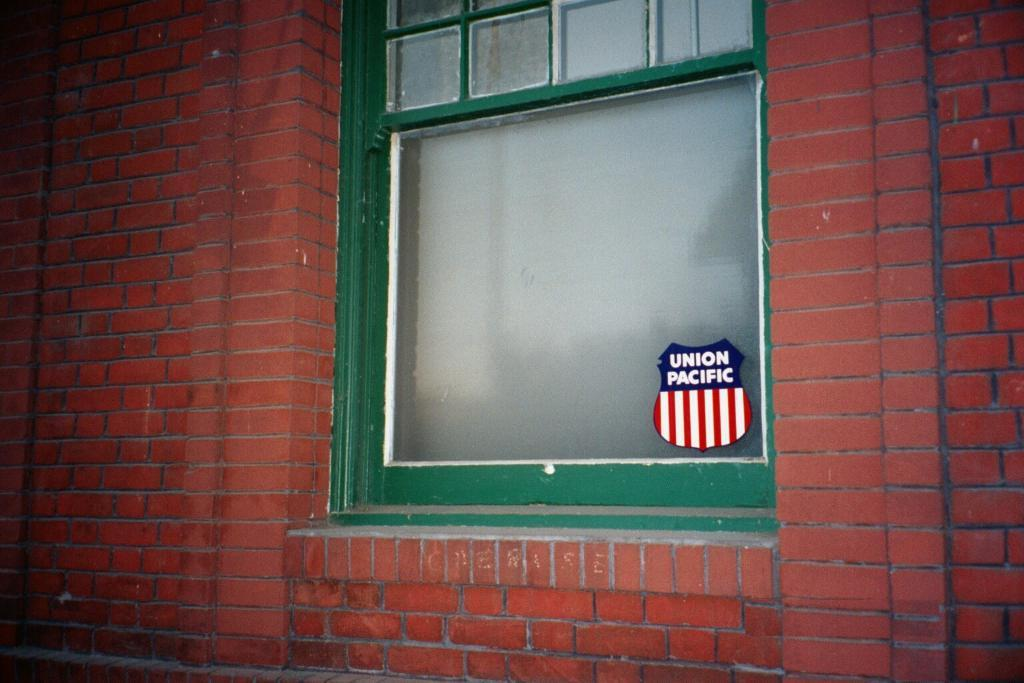<image>
Summarize the visual content of the image. A red brick wall with a green sliding window with a sticker of Union Pacific 